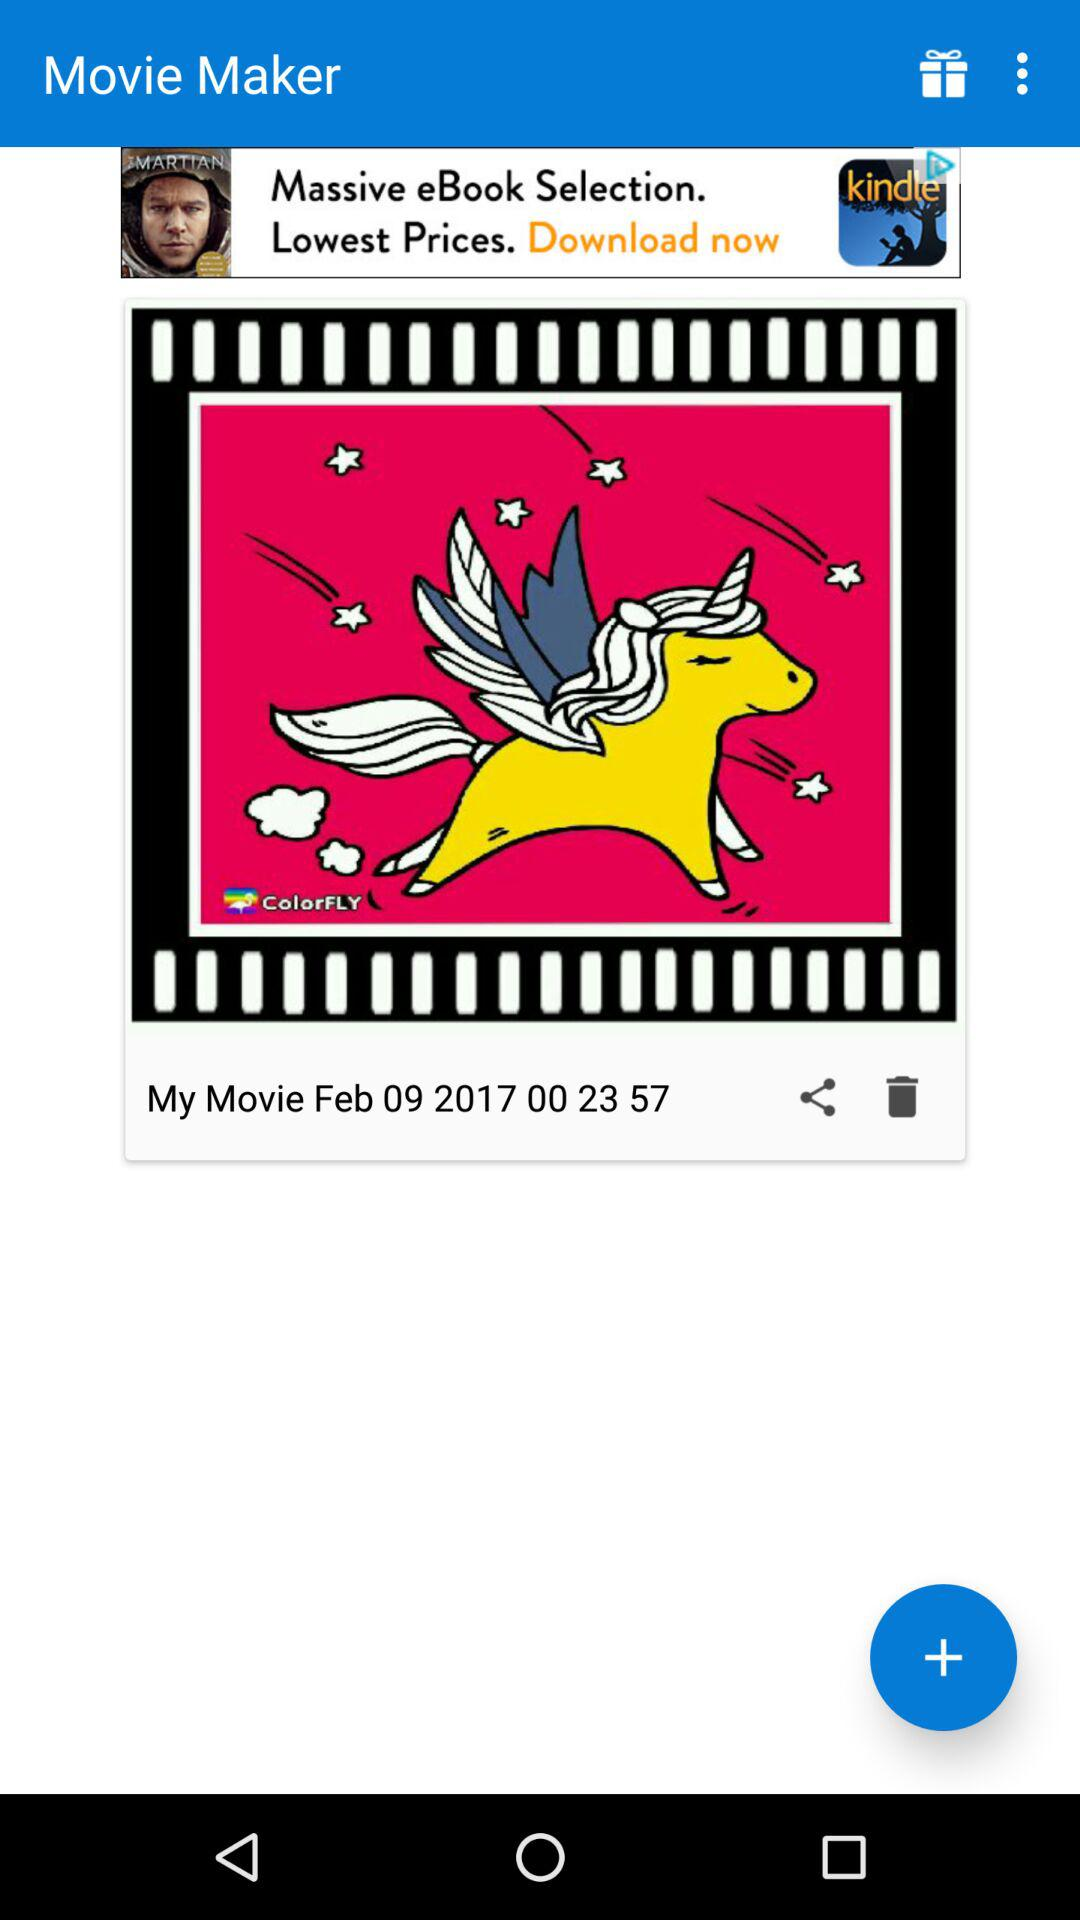What is the date? The date is February 9, 2017. 